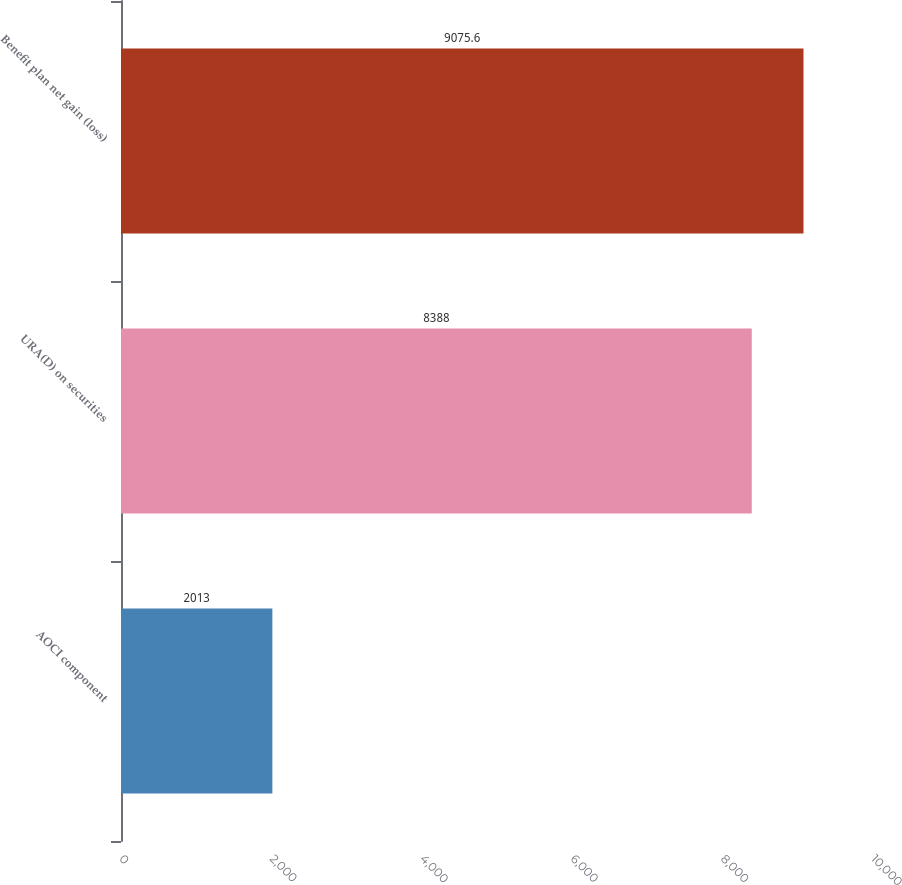<chart> <loc_0><loc_0><loc_500><loc_500><bar_chart><fcel>AOCI component<fcel>URA(D) on securities<fcel>Benefit plan net gain (loss)<nl><fcel>2013<fcel>8388<fcel>9075.6<nl></chart> 